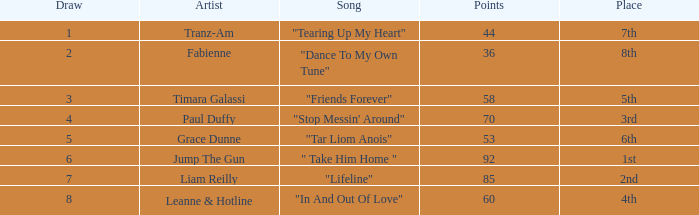What's the average draw for the song "stop messin' around"? 4.0. 